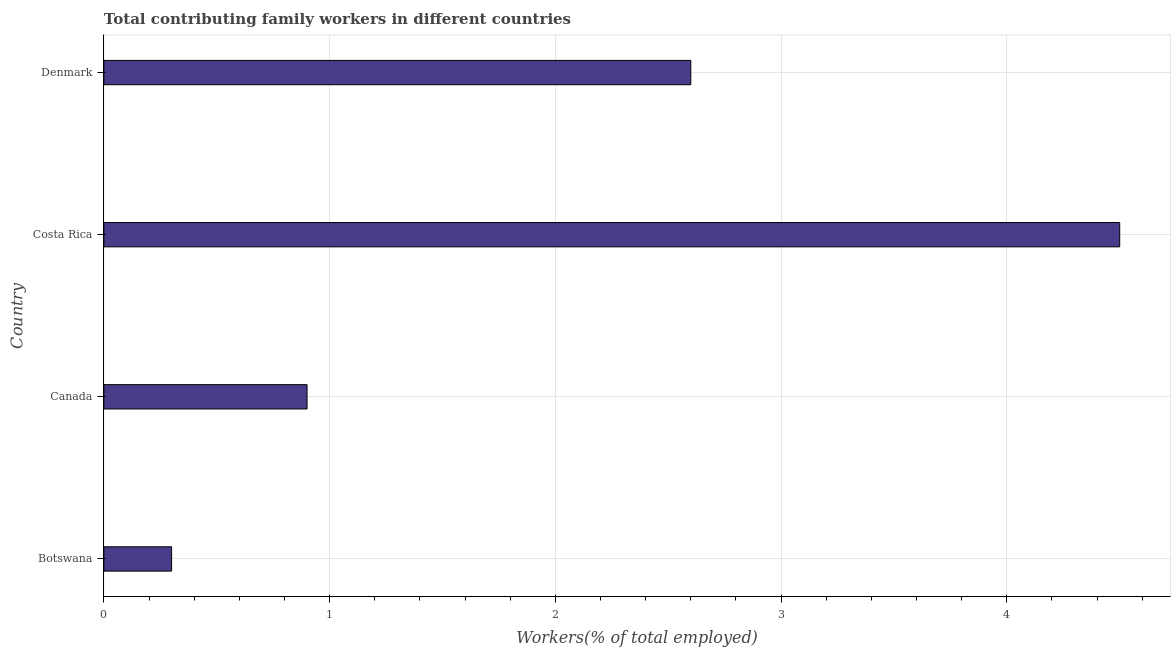Does the graph contain grids?
Give a very brief answer. Yes. What is the title of the graph?
Give a very brief answer. Total contributing family workers in different countries. What is the label or title of the X-axis?
Your response must be concise. Workers(% of total employed). What is the contributing family workers in Canada?
Your answer should be compact. 0.9. Across all countries, what is the maximum contributing family workers?
Provide a succinct answer. 4.5. Across all countries, what is the minimum contributing family workers?
Ensure brevity in your answer.  0.3. In which country was the contributing family workers maximum?
Your answer should be very brief. Costa Rica. In which country was the contributing family workers minimum?
Your answer should be compact. Botswana. What is the sum of the contributing family workers?
Your answer should be compact. 8.3. What is the average contributing family workers per country?
Your answer should be compact. 2.08. What is the median contributing family workers?
Your answer should be very brief. 1.75. What is the ratio of the contributing family workers in Botswana to that in Canada?
Your response must be concise. 0.33. Is the difference between the contributing family workers in Canada and Denmark greater than the difference between any two countries?
Your answer should be very brief. No. What is the difference between the highest and the lowest contributing family workers?
Your response must be concise. 4.2. Are all the bars in the graph horizontal?
Ensure brevity in your answer.  Yes. How many countries are there in the graph?
Your response must be concise. 4. What is the difference between two consecutive major ticks on the X-axis?
Make the answer very short. 1. What is the Workers(% of total employed) in Botswana?
Keep it short and to the point. 0.3. What is the Workers(% of total employed) of Canada?
Ensure brevity in your answer.  0.9. What is the Workers(% of total employed) in Costa Rica?
Provide a succinct answer. 4.5. What is the Workers(% of total employed) of Denmark?
Provide a short and direct response. 2.6. What is the difference between the Workers(% of total employed) in Botswana and Canada?
Offer a very short reply. -0.6. What is the difference between the Workers(% of total employed) in Botswana and Denmark?
Your response must be concise. -2.3. What is the difference between the Workers(% of total employed) in Canada and Denmark?
Give a very brief answer. -1.7. What is the ratio of the Workers(% of total employed) in Botswana to that in Canada?
Keep it short and to the point. 0.33. What is the ratio of the Workers(% of total employed) in Botswana to that in Costa Rica?
Your response must be concise. 0.07. What is the ratio of the Workers(% of total employed) in Botswana to that in Denmark?
Give a very brief answer. 0.12. What is the ratio of the Workers(% of total employed) in Canada to that in Costa Rica?
Ensure brevity in your answer.  0.2. What is the ratio of the Workers(% of total employed) in Canada to that in Denmark?
Provide a succinct answer. 0.35. What is the ratio of the Workers(% of total employed) in Costa Rica to that in Denmark?
Provide a succinct answer. 1.73. 